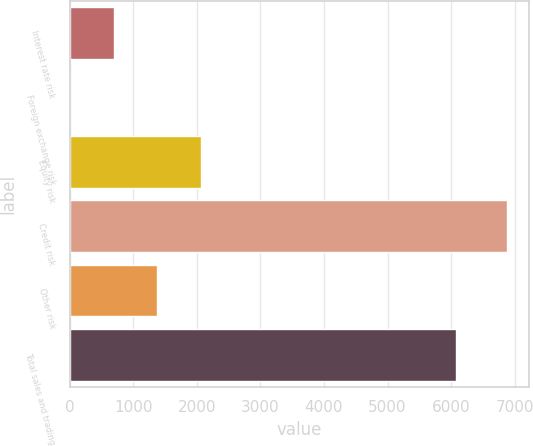Convert chart to OTSL. <chart><loc_0><loc_0><loc_500><loc_500><bar_chart><fcel>Interest rate risk<fcel>Foreign exchange risk<fcel>Equity risk<fcel>Credit risk<fcel>Other risk<fcel>Total sales and trading<nl><fcel>693.5<fcel>6<fcel>2068.5<fcel>6881<fcel>1381<fcel>6084<nl></chart> 